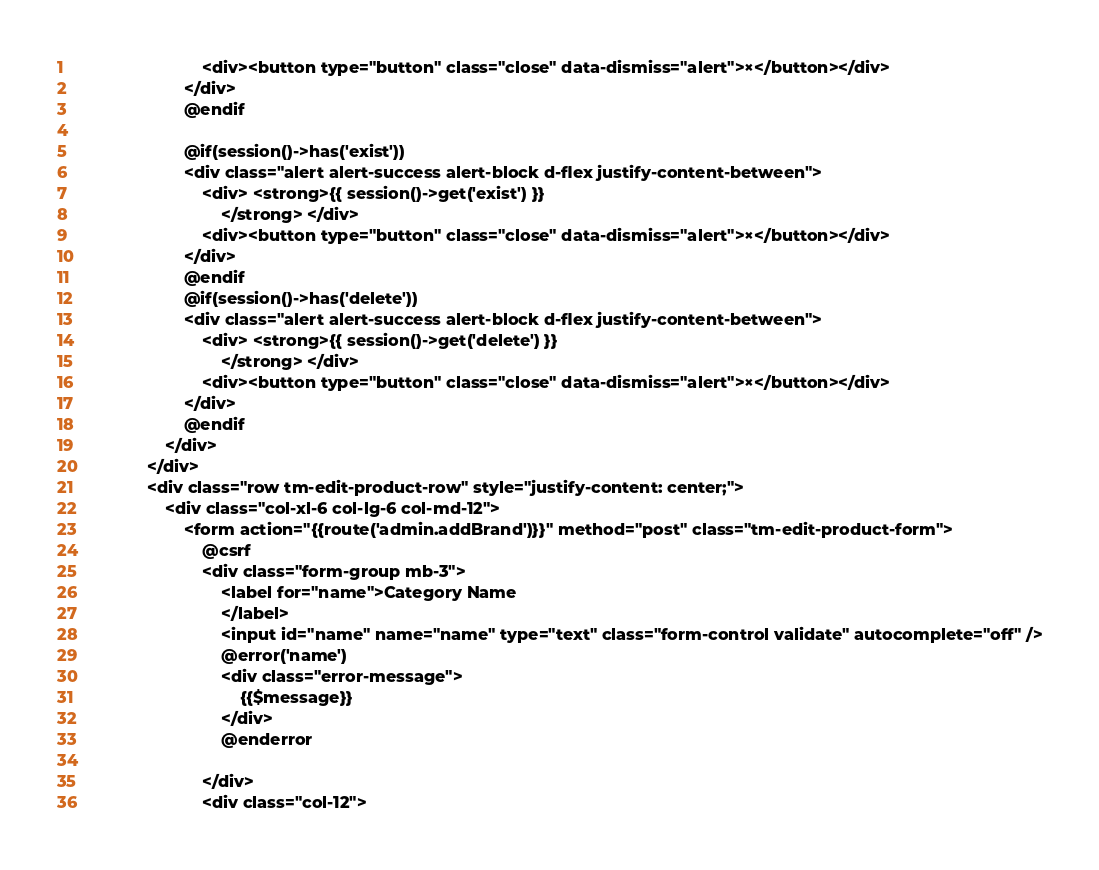Convert code to text. <code><loc_0><loc_0><loc_500><loc_500><_PHP_>                            <div><button type="button" class="close" data-dismiss="alert">×</button></div>
                        </div>
                        @endif

                        @if(session()->has('exist'))
                        <div class="alert alert-success alert-block d-flex justify-content-between">
                            <div> <strong>{{ session()->get('exist') }}
                                </strong> </div>
                            <div><button type="button" class="close" data-dismiss="alert">×</button></div>
                        </div>
                        @endif
                        @if(session()->has('delete'))
                        <div class="alert alert-success alert-block d-flex justify-content-between">
                            <div> <strong>{{ session()->get('delete') }}
                                </strong> </div>
                            <div><button type="button" class="close" data-dismiss="alert">×</button></div>
                        </div>
                        @endif
                    </div>
                </div>
                <div class="row tm-edit-product-row" style="justify-content: center;">
                    <div class="col-xl-6 col-lg-6 col-md-12">
                        <form action="{{route('admin.addBrand')}}" method="post" class="tm-edit-product-form">
                            @csrf
                            <div class="form-group mb-3">
                                <label for="name">Category Name
                                </label>
                                <input id="name" name="name" type="text" class="form-control validate" autocomplete="off" />
                                @error('name')
                                <div class="error-message">
                                    {{$message}}
                                </div>
                                @enderror

                            </div>
                            <div class="col-12"></code> 